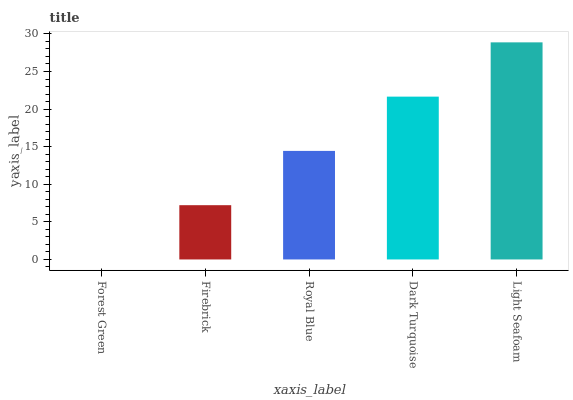Is Forest Green the minimum?
Answer yes or no. Yes. Is Light Seafoam the maximum?
Answer yes or no. Yes. Is Firebrick the minimum?
Answer yes or no. No. Is Firebrick the maximum?
Answer yes or no. No. Is Firebrick greater than Forest Green?
Answer yes or no. Yes. Is Forest Green less than Firebrick?
Answer yes or no. Yes. Is Forest Green greater than Firebrick?
Answer yes or no. No. Is Firebrick less than Forest Green?
Answer yes or no. No. Is Royal Blue the high median?
Answer yes or no. Yes. Is Royal Blue the low median?
Answer yes or no. Yes. Is Light Seafoam the high median?
Answer yes or no. No. Is Forest Green the low median?
Answer yes or no. No. 